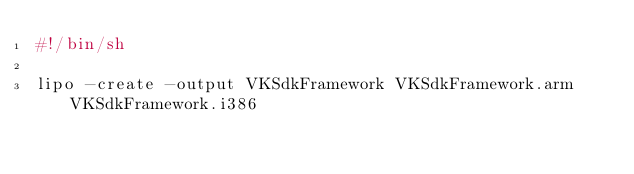<code> <loc_0><loc_0><loc_500><loc_500><_Bash_>#!/bin/sh

lipo -create -output VKSdkFramework VKSdkFramework.arm VKSdkFramework.i386
</code> 